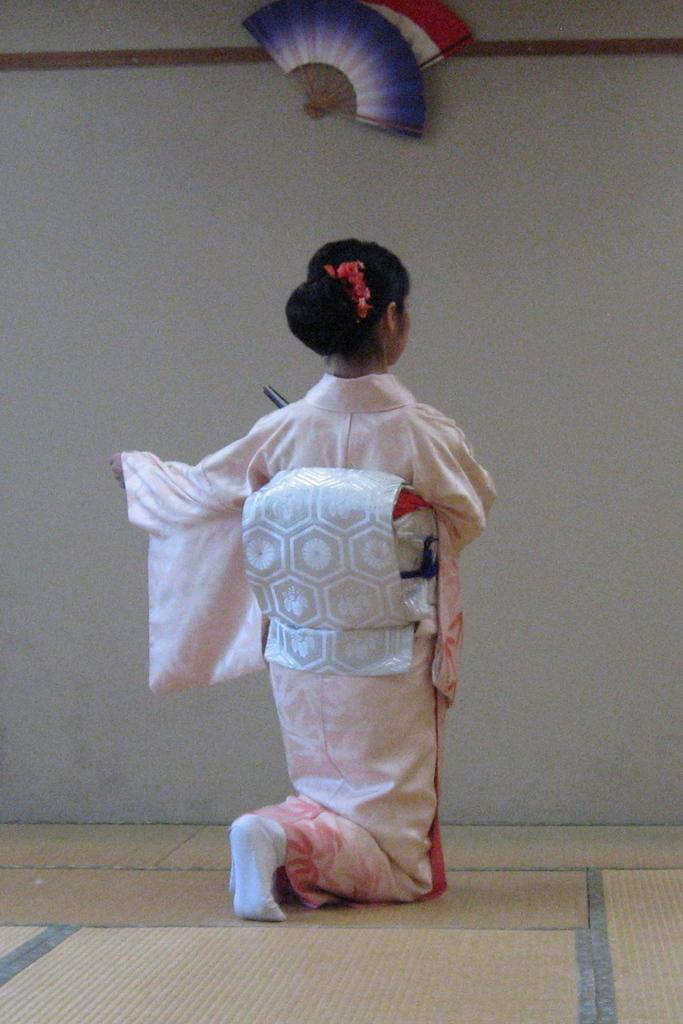Who is present in the image? There is a girl in the image. What is the girl wearing? The girl is wearing a dress. What type of apparel is the girl using to play chess in the image? There is no chess or apparel related to chess present in the image. How many rabbits can be seen interacting with the girl in the image? There are no rabbits present in the image. 